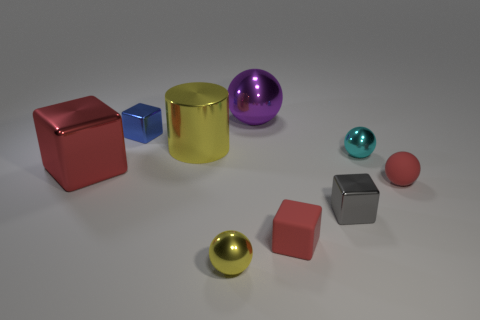Add 1 tiny matte blocks. How many objects exist? 10 Subtract all cylinders. How many objects are left? 8 Add 7 tiny cyan metal objects. How many tiny cyan metal objects exist? 8 Subtract 1 yellow cylinders. How many objects are left? 8 Subtract all small cyan metal balls. Subtract all tiny cyan balls. How many objects are left? 7 Add 1 yellow objects. How many yellow objects are left? 3 